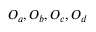Convert formula to latex. <formula><loc_0><loc_0><loc_500><loc_500>O _ { a } , O _ { b } , O _ { c } , O _ { d }</formula> 